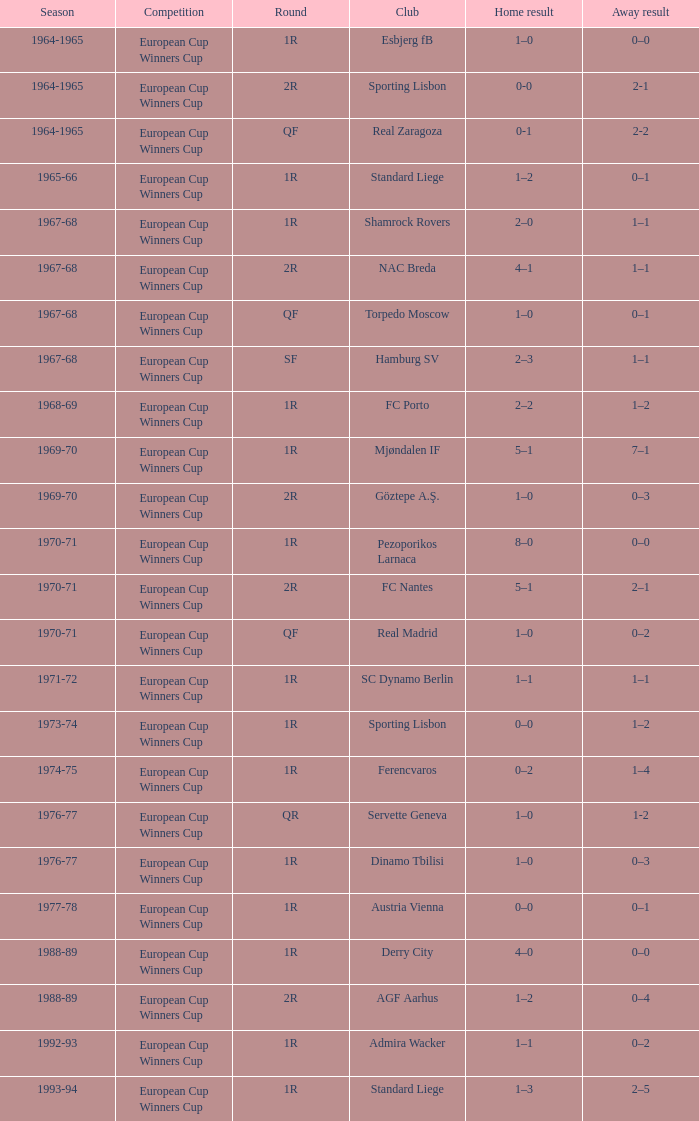Which club is related to a 1-1 draw away, a 1r stage, and the 1967-68 season? Shamrock Rovers. 